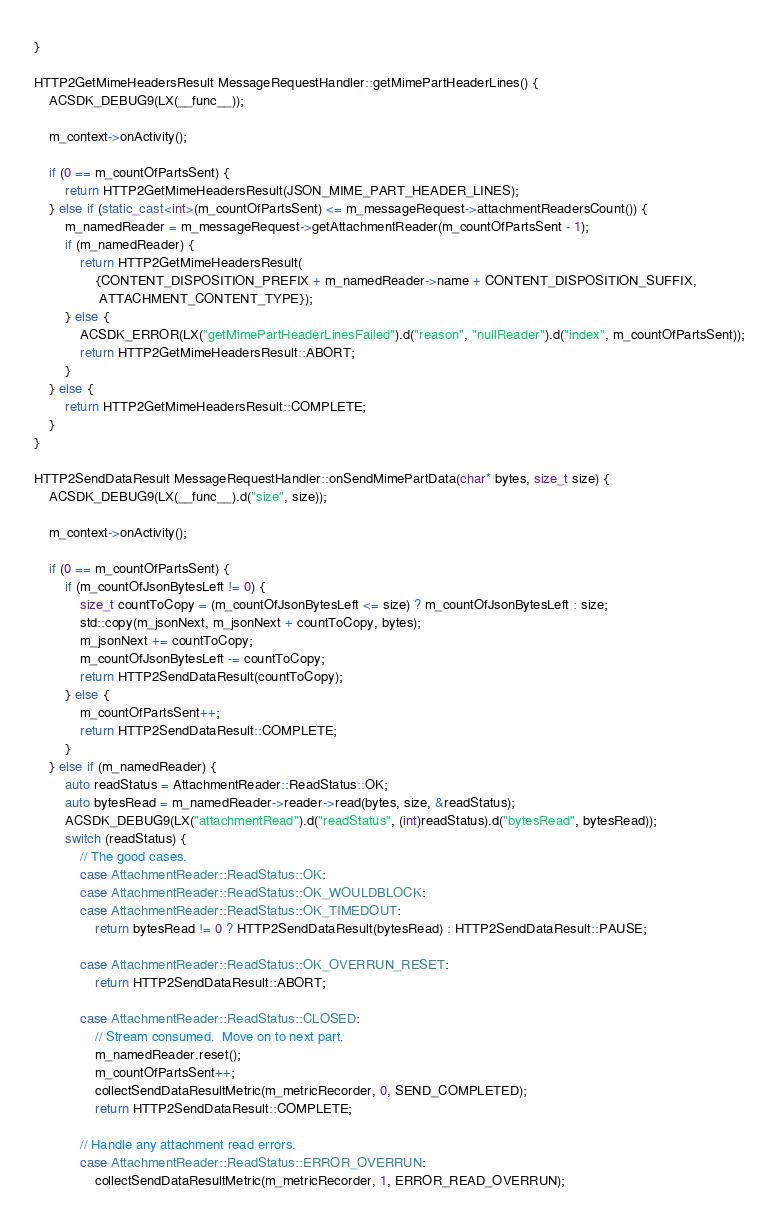Convert code to text. <code><loc_0><loc_0><loc_500><loc_500><_C++_>}

HTTP2GetMimeHeadersResult MessageRequestHandler::getMimePartHeaderLines() {
    ACSDK_DEBUG9(LX(__func__));

    m_context->onActivity();

    if (0 == m_countOfPartsSent) {
        return HTTP2GetMimeHeadersResult(JSON_MIME_PART_HEADER_LINES);
    } else if (static_cast<int>(m_countOfPartsSent) <= m_messageRequest->attachmentReadersCount()) {
        m_namedReader = m_messageRequest->getAttachmentReader(m_countOfPartsSent - 1);
        if (m_namedReader) {
            return HTTP2GetMimeHeadersResult(
                {CONTENT_DISPOSITION_PREFIX + m_namedReader->name + CONTENT_DISPOSITION_SUFFIX,
                 ATTACHMENT_CONTENT_TYPE});
        } else {
            ACSDK_ERROR(LX("getMimePartHeaderLinesFailed").d("reason", "nullReader").d("index", m_countOfPartsSent));
            return HTTP2GetMimeHeadersResult::ABORT;
        }
    } else {
        return HTTP2GetMimeHeadersResult::COMPLETE;
    }
}

HTTP2SendDataResult MessageRequestHandler::onSendMimePartData(char* bytes, size_t size) {
    ACSDK_DEBUG9(LX(__func__).d("size", size));

    m_context->onActivity();

    if (0 == m_countOfPartsSent) {
        if (m_countOfJsonBytesLeft != 0) {
            size_t countToCopy = (m_countOfJsonBytesLeft <= size) ? m_countOfJsonBytesLeft : size;
            std::copy(m_jsonNext, m_jsonNext + countToCopy, bytes);
            m_jsonNext += countToCopy;
            m_countOfJsonBytesLeft -= countToCopy;
            return HTTP2SendDataResult(countToCopy);
        } else {
            m_countOfPartsSent++;
            return HTTP2SendDataResult::COMPLETE;
        }
    } else if (m_namedReader) {
        auto readStatus = AttachmentReader::ReadStatus::OK;
        auto bytesRead = m_namedReader->reader->read(bytes, size, &readStatus);
        ACSDK_DEBUG9(LX("attachmentRead").d("readStatus", (int)readStatus).d("bytesRead", bytesRead));
        switch (readStatus) {
            // The good cases.
            case AttachmentReader::ReadStatus::OK:
            case AttachmentReader::ReadStatus::OK_WOULDBLOCK:
            case AttachmentReader::ReadStatus::OK_TIMEDOUT:
                return bytesRead != 0 ? HTTP2SendDataResult(bytesRead) : HTTP2SendDataResult::PAUSE;

            case AttachmentReader::ReadStatus::OK_OVERRUN_RESET:
                return HTTP2SendDataResult::ABORT;

            case AttachmentReader::ReadStatus::CLOSED:
                // Stream consumed.  Move on to next part.
                m_namedReader.reset();
                m_countOfPartsSent++;
                collectSendDataResultMetric(m_metricRecorder, 0, SEND_COMPLETED);
                return HTTP2SendDataResult::COMPLETE;

            // Handle any attachment read errors.
            case AttachmentReader::ReadStatus::ERROR_OVERRUN:
                collectSendDataResultMetric(m_metricRecorder, 1, ERROR_READ_OVERRUN);</code> 